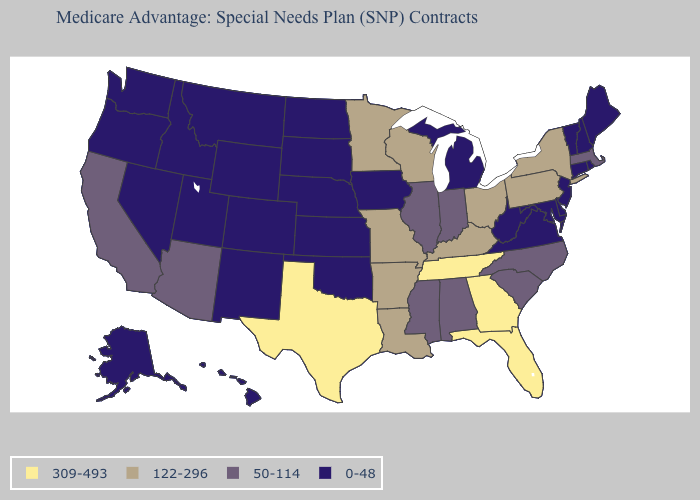Name the states that have a value in the range 309-493?
Answer briefly. Florida, Georgia, Tennessee, Texas. Which states hav the highest value in the West?
Be succinct. Arizona, California. What is the value of Connecticut?
Be succinct. 0-48. Does Nevada have a lower value than Kentucky?
Keep it brief. Yes. Does West Virginia have the same value as Maine?
Short answer required. Yes. Is the legend a continuous bar?
Give a very brief answer. No. Name the states that have a value in the range 309-493?
Quick response, please. Florida, Georgia, Tennessee, Texas. Name the states that have a value in the range 309-493?
Quick response, please. Florida, Georgia, Tennessee, Texas. What is the value of South Dakota?
Keep it brief. 0-48. What is the lowest value in states that border Nebraska?
Write a very short answer. 0-48. Name the states that have a value in the range 50-114?
Write a very short answer. Alabama, Arizona, California, Illinois, Indiana, Massachusetts, Mississippi, North Carolina, South Carolina. What is the value of North Carolina?
Concise answer only. 50-114. Which states have the highest value in the USA?
Write a very short answer. Florida, Georgia, Tennessee, Texas. Which states have the highest value in the USA?
Answer briefly. Florida, Georgia, Tennessee, Texas. What is the value of Nevada?
Quick response, please. 0-48. 